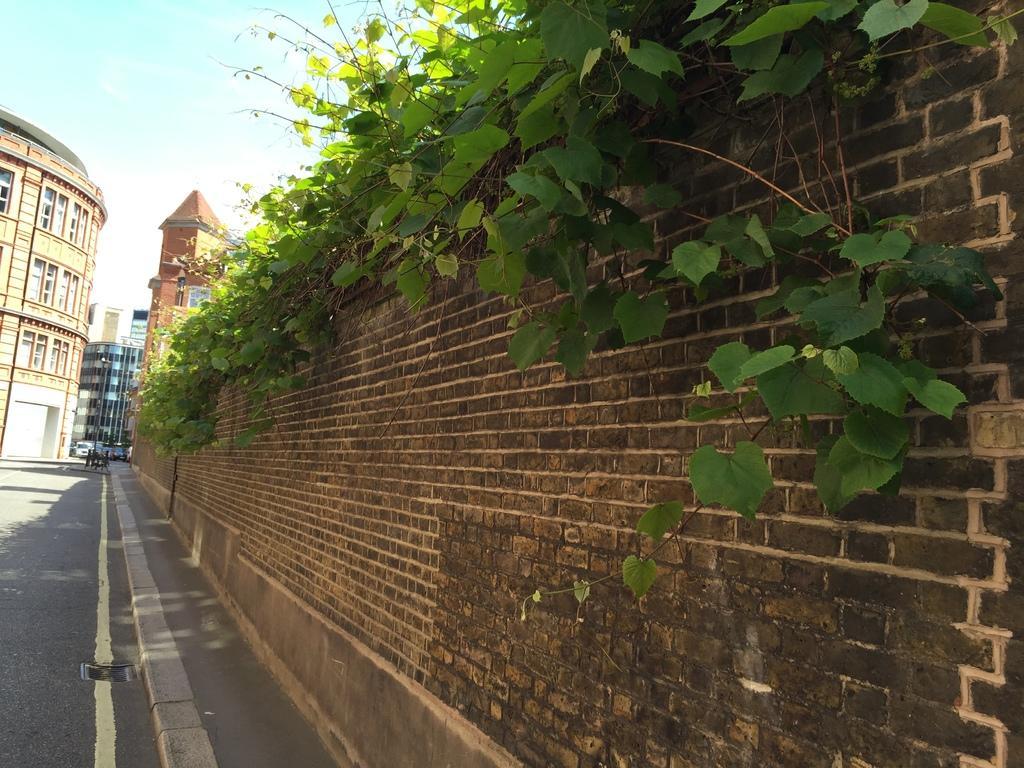Can you describe this image briefly? In this image I can see the wall and the plants. To the side of the wall I can see the road. In the background I can see the buildings and the sky. 